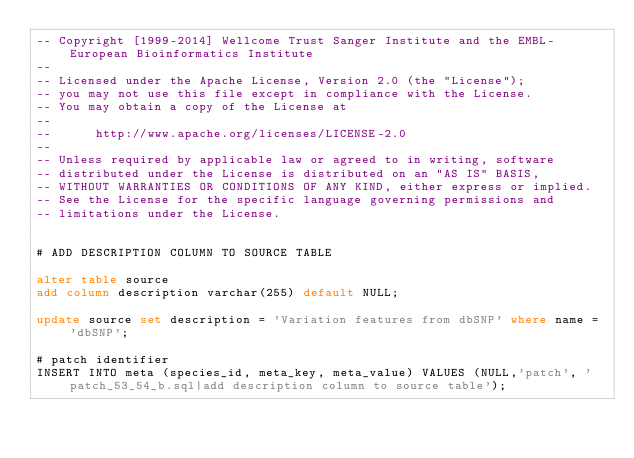Convert code to text. <code><loc_0><loc_0><loc_500><loc_500><_SQL_>-- Copyright [1999-2014] Wellcome Trust Sanger Institute and the EMBL-European Bioinformatics Institute
-- 
-- Licensed under the Apache License, Version 2.0 (the "License");
-- you may not use this file except in compliance with the License.
-- You may obtain a copy of the License at
-- 
--      http://www.apache.org/licenses/LICENSE-2.0
-- 
-- Unless required by applicable law or agreed to in writing, software
-- distributed under the License is distributed on an "AS IS" BASIS,
-- WITHOUT WARRANTIES OR CONDITIONS OF ANY KIND, either express or implied.
-- See the License for the specific language governing permissions and
-- limitations under the License.


# ADD DESCRIPTION COLUMN TO SOURCE TABLE

alter table source
add column description varchar(255) default NULL;

update source set description = 'Variation features from dbSNP' where name = 'dbSNP';

# patch identifier
INSERT INTO meta (species_id, meta_key, meta_value) VALUES (NULL,'patch', 'patch_53_54_b.sql|add description column to source table');
</code> 